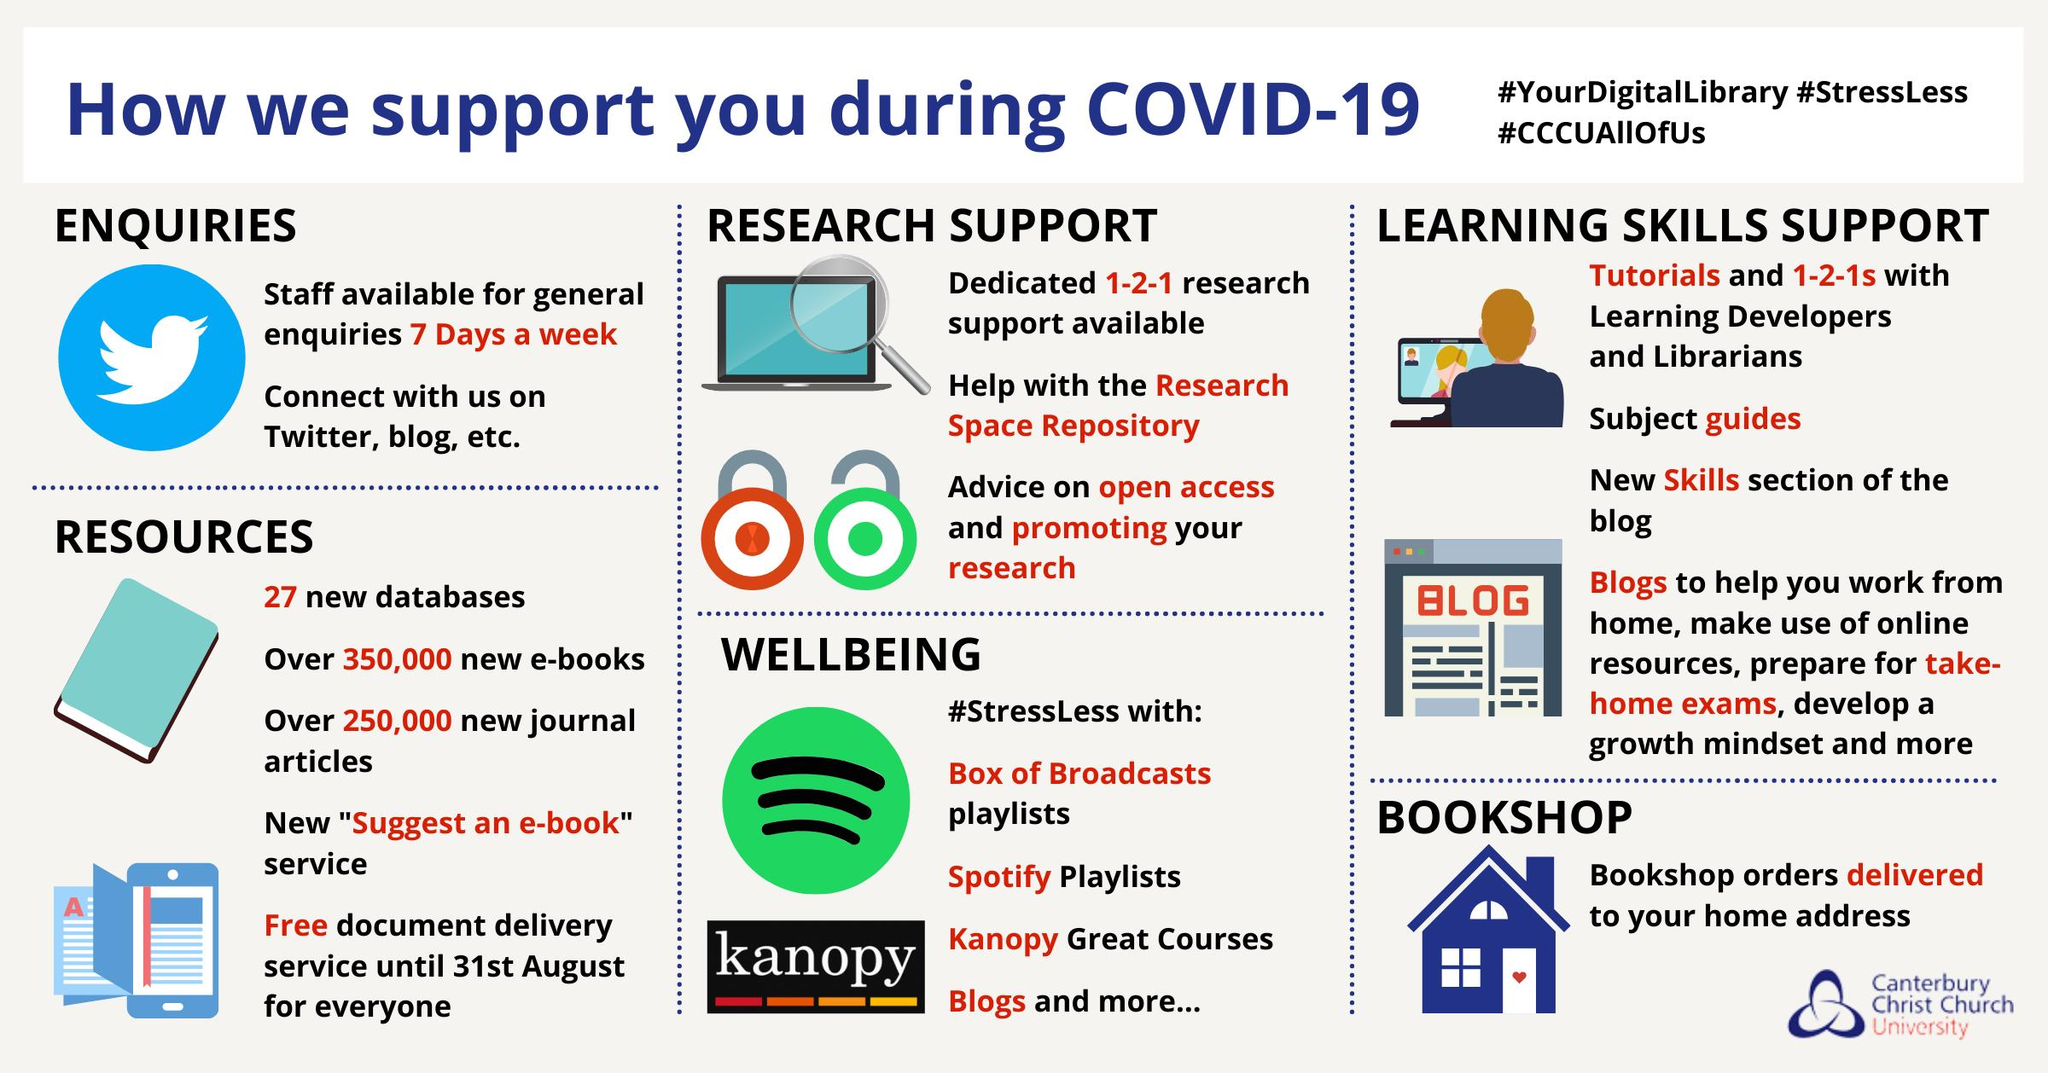Indicate a few pertinent items in this graphic. The second item listed under wellbeing is Spotify playlists. The library may be contacted through Twitter and a blog for inquiries and updates. There are five items listed under the resource section. There are available resources, such as blogs, that can assist members in working from home or preparing for take-home exams. Until the end of August, a free document delivery service is available. 